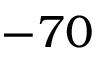Convert formula to latex. <formula><loc_0><loc_0><loc_500><loc_500>- 7 0</formula> 